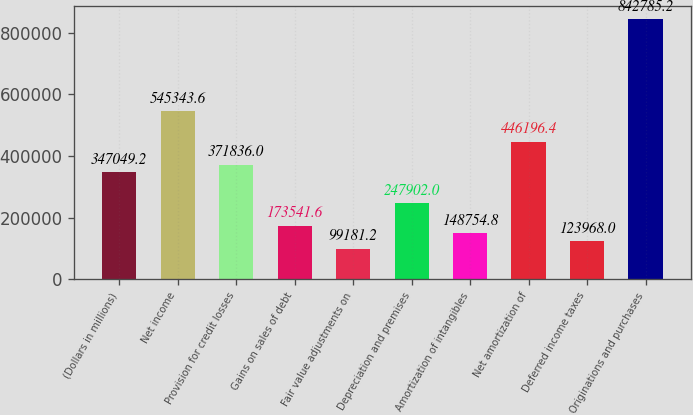Convert chart. <chart><loc_0><loc_0><loc_500><loc_500><bar_chart><fcel>(Dollars in millions)<fcel>Net income<fcel>Provision for credit losses<fcel>Gains on sales of debt<fcel>Fair value adjustments on<fcel>Depreciation and premises<fcel>Amortization of intangibles<fcel>Net amortization of<fcel>Deferred income taxes<fcel>Originations and purchases<nl><fcel>347049<fcel>545344<fcel>371836<fcel>173542<fcel>99181.2<fcel>247902<fcel>148755<fcel>446196<fcel>123968<fcel>842785<nl></chart> 